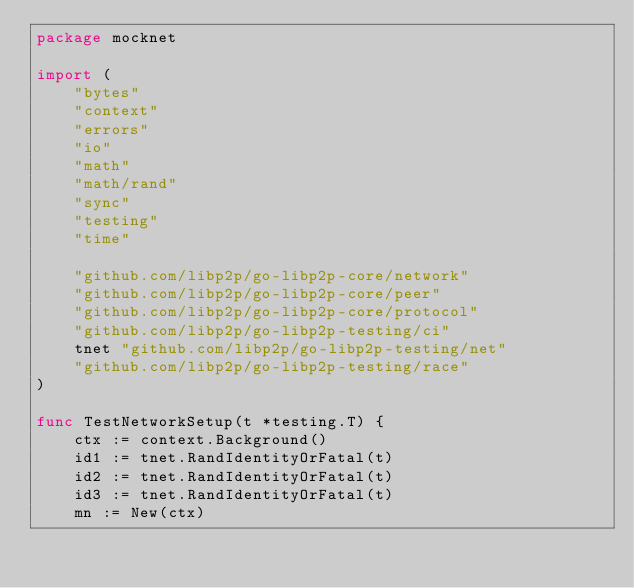<code> <loc_0><loc_0><loc_500><loc_500><_Go_>package mocknet

import (
	"bytes"
	"context"
	"errors"
	"io"
	"math"
	"math/rand"
	"sync"
	"testing"
	"time"

	"github.com/libp2p/go-libp2p-core/network"
	"github.com/libp2p/go-libp2p-core/peer"
	"github.com/libp2p/go-libp2p-core/protocol"
	"github.com/libp2p/go-libp2p-testing/ci"
	tnet "github.com/libp2p/go-libp2p-testing/net"
	"github.com/libp2p/go-libp2p-testing/race"
)

func TestNetworkSetup(t *testing.T) {
	ctx := context.Background()
	id1 := tnet.RandIdentityOrFatal(t)
	id2 := tnet.RandIdentityOrFatal(t)
	id3 := tnet.RandIdentityOrFatal(t)
	mn := New(ctx)</code> 